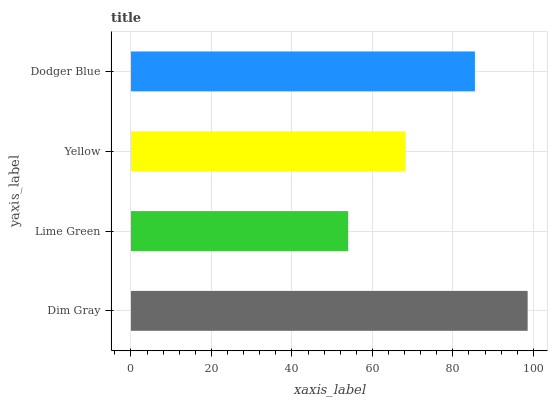Is Lime Green the minimum?
Answer yes or no. Yes. Is Dim Gray the maximum?
Answer yes or no. Yes. Is Yellow the minimum?
Answer yes or no. No. Is Yellow the maximum?
Answer yes or no. No. Is Yellow greater than Lime Green?
Answer yes or no. Yes. Is Lime Green less than Yellow?
Answer yes or no. Yes. Is Lime Green greater than Yellow?
Answer yes or no. No. Is Yellow less than Lime Green?
Answer yes or no. No. Is Dodger Blue the high median?
Answer yes or no. Yes. Is Yellow the low median?
Answer yes or no. Yes. Is Yellow the high median?
Answer yes or no. No. Is Lime Green the low median?
Answer yes or no. No. 